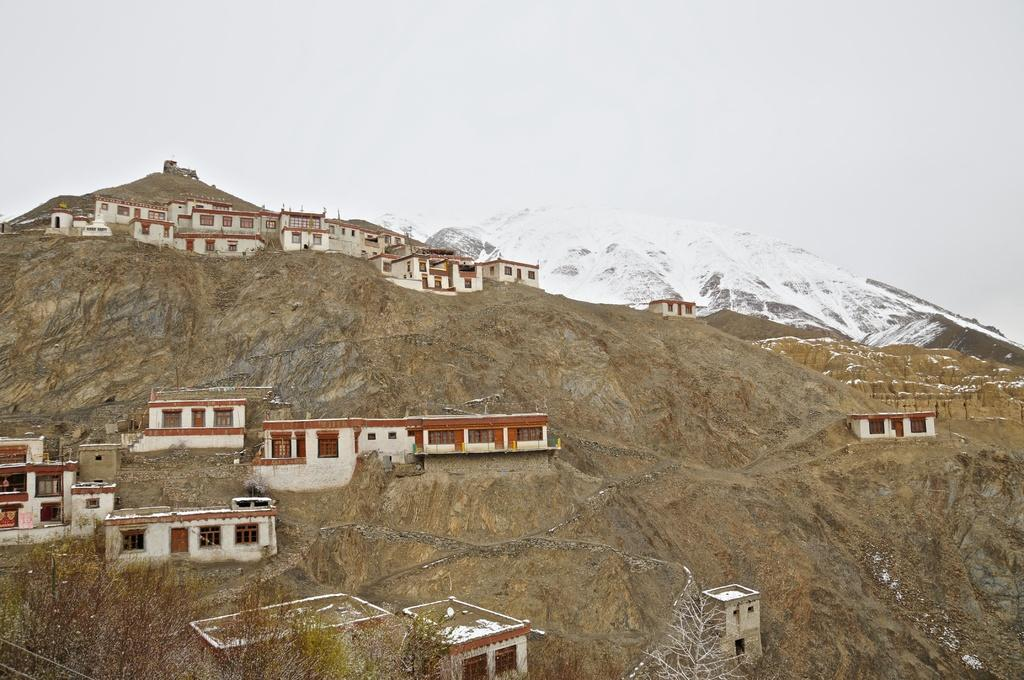Where are the houses located in the image? The houses are on a mountain in the image. How are the houses arranged on the mountain? The houses are in random places on the mountain. What can be seen in the background of the image? There is a snow mountain and the sky visible in the background. What type of vegetation is present at the bottom of the image? There are plants on the left at the bottom of the image. Where is the library located in the image? There is no library present in the image. What type of beef is being served at the town gathering in the image? There is no town or beef present in the image; it features houses on a mountain with a snow mountain in the background. 